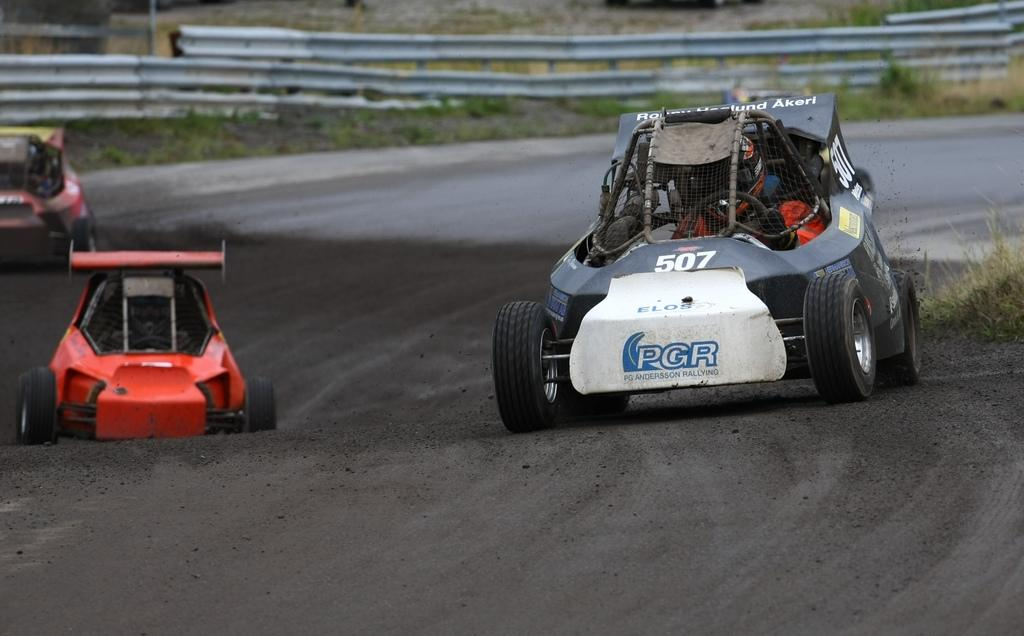What type of vehicles are in the image? There are sports cars in the image. What are the sports cars doing in the image? The sports cars are moving on the road. What type of vegetation can be seen in the image? There is grass visible in the image. How would you describe the background of the image? The background of the image is blurred. What architectural feature is present in the background of the image? There is a fence in the background of the image. What type of canvas is being used to paint the flame in the image? There is no canvas or flame present in the image; it features sports cars moving on the road. How hot is the hot air balloon in the image? There is no hot air balloon present in the image. 